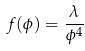Convert formula to latex. <formula><loc_0><loc_0><loc_500><loc_500>f ( \phi ) = \frac { \lambda } { \phi ^ { 4 } }</formula> 